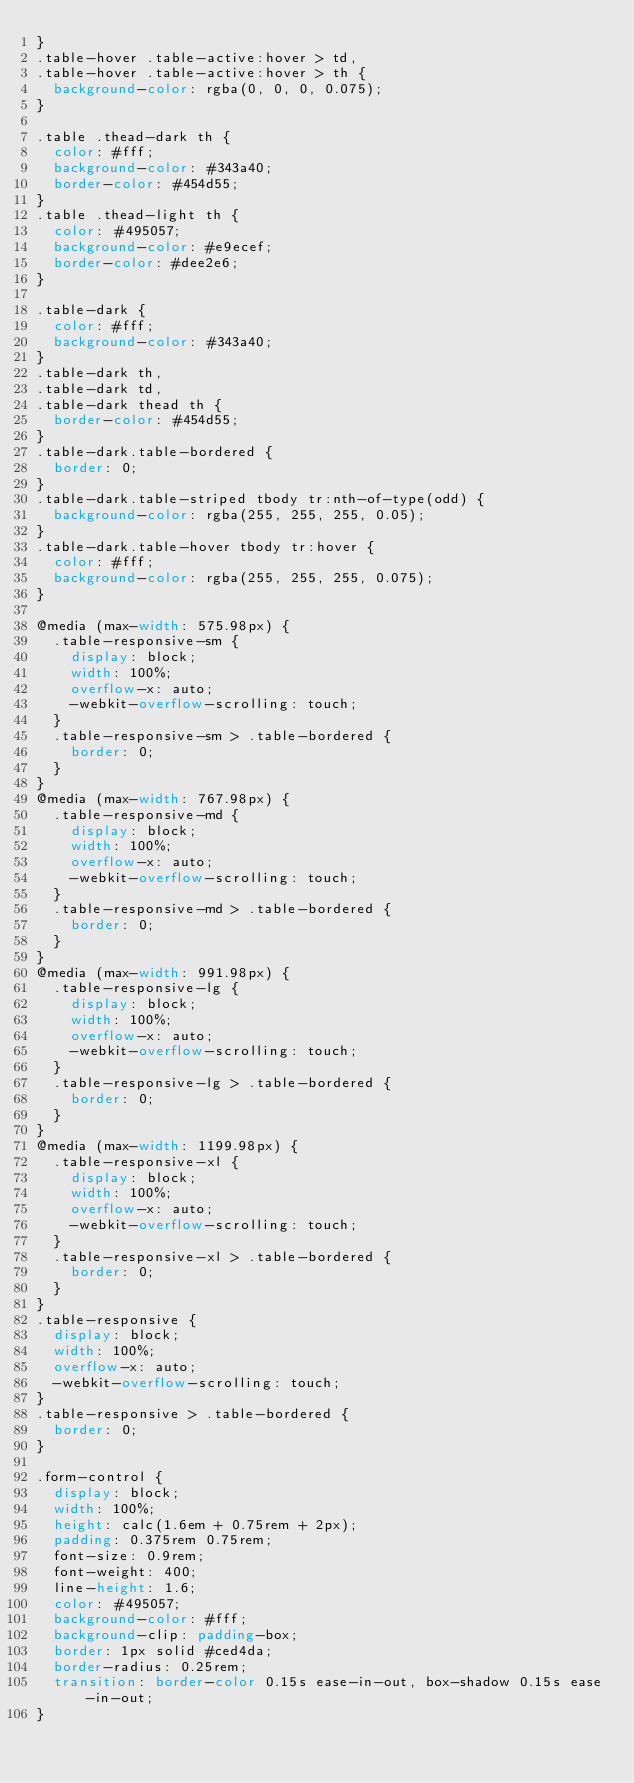<code> <loc_0><loc_0><loc_500><loc_500><_CSS_>}
.table-hover .table-active:hover > td,
.table-hover .table-active:hover > th {
  background-color: rgba(0, 0, 0, 0.075);
}

.table .thead-dark th {
  color: #fff;
  background-color: #343a40;
  border-color: #454d55;
}
.table .thead-light th {
  color: #495057;
  background-color: #e9ecef;
  border-color: #dee2e6;
}

.table-dark {
  color: #fff;
  background-color: #343a40;
}
.table-dark th,
.table-dark td,
.table-dark thead th {
  border-color: #454d55;
}
.table-dark.table-bordered {
  border: 0;
}
.table-dark.table-striped tbody tr:nth-of-type(odd) {
  background-color: rgba(255, 255, 255, 0.05);
}
.table-dark.table-hover tbody tr:hover {
  color: #fff;
  background-color: rgba(255, 255, 255, 0.075);
}

@media (max-width: 575.98px) {
  .table-responsive-sm {
    display: block;
    width: 100%;
    overflow-x: auto;
    -webkit-overflow-scrolling: touch;
  }
  .table-responsive-sm > .table-bordered {
    border: 0;
  }
}
@media (max-width: 767.98px) {
  .table-responsive-md {
    display: block;
    width: 100%;
    overflow-x: auto;
    -webkit-overflow-scrolling: touch;
  }
  .table-responsive-md > .table-bordered {
    border: 0;
  }
}
@media (max-width: 991.98px) {
  .table-responsive-lg {
    display: block;
    width: 100%;
    overflow-x: auto;
    -webkit-overflow-scrolling: touch;
  }
  .table-responsive-lg > .table-bordered {
    border: 0;
  }
}
@media (max-width: 1199.98px) {
  .table-responsive-xl {
    display: block;
    width: 100%;
    overflow-x: auto;
    -webkit-overflow-scrolling: touch;
  }
  .table-responsive-xl > .table-bordered {
    border: 0;
  }
}
.table-responsive {
  display: block;
  width: 100%;
  overflow-x: auto;
  -webkit-overflow-scrolling: touch;
}
.table-responsive > .table-bordered {
  border: 0;
}

.form-control {
  display: block;
  width: 100%;
  height: calc(1.6em + 0.75rem + 2px);
  padding: 0.375rem 0.75rem;
  font-size: 0.9rem;
  font-weight: 400;
  line-height: 1.6;
  color: #495057;
  background-color: #fff;
  background-clip: padding-box;
  border: 1px solid #ced4da;
  border-radius: 0.25rem;
  transition: border-color 0.15s ease-in-out, box-shadow 0.15s ease-in-out;
}</code> 